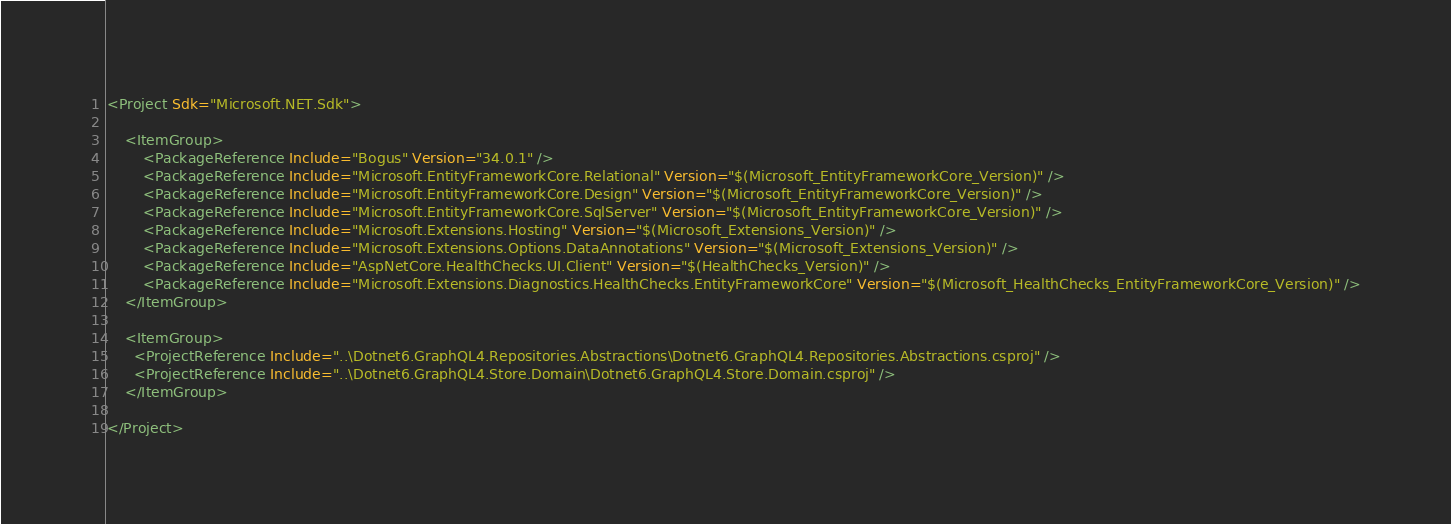<code> <loc_0><loc_0><loc_500><loc_500><_XML_><Project Sdk="Microsoft.NET.Sdk">
    
    <ItemGroup>
        <PackageReference Include="Bogus" Version="34.0.1" />
        <PackageReference Include="Microsoft.EntityFrameworkCore.Relational" Version="$(Microsoft_EntityFrameworkCore_Version)" />
        <PackageReference Include="Microsoft.EntityFrameworkCore.Design" Version="$(Microsoft_EntityFrameworkCore_Version)" />
        <PackageReference Include="Microsoft.EntityFrameworkCore.SqlServer" Version="$(Microsoft_EntityFrameworkCore_Version)" />
        <PackageReference Include="Microsoft.Extensions.Hosting" Version="$(Microsoft_Extensions_Version)" />
        <PackageReference Include="Microsoft.Extensions.Options.DataAnnotations" Version="$(Microsoft_Extensions_Version)" />
        <PackageReference Include="AspNetCore.HealthChecks.UI.Client" Version="$(HealthChecks_Version)" />
        <PackageReference Include="Microsoft.Extensions.Diagnostics.HealthChecks.EntityFrameworkCore" Version="$(Microsoft_HealthChecks_EntityFrameworkCore_Version)" />
    </ItemGroup>
    
    <ItemGroup>
      <ProjectReference Include="..\Dotnet6.GraphQL4.Repositories.Abstractions\Dotnet6.GraphQL4.Repositories.Abstractions.csproj" />
      <ProjectReference Include="..\Dotnet6.GraphQL4.Store.Domain\Dotnet6.GraphQL4.Store.Domain.csproj" />
    </ItemGroup>
    
</Project>
</code> 